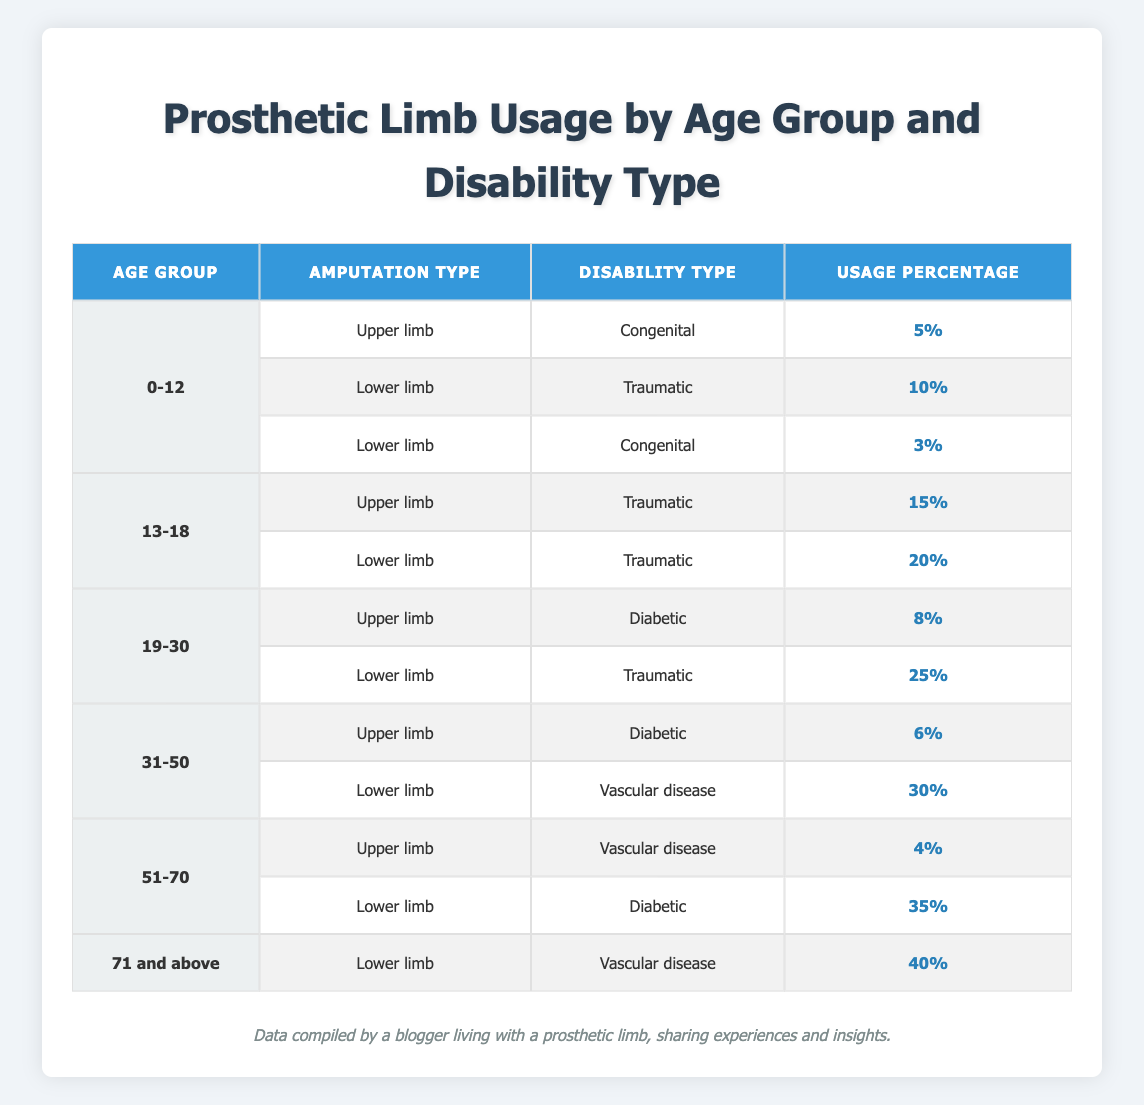What is the usage percentage for upper limb prosthetics among children aged 0-12 with congenital disabilities? In the table, we look for the row where the age group is 0-12, the amputation type is upper limb, and the disability type is congenital. There is one such row, which shows a usage percentage of 5%.
Answer: 5% Which age group has the highest usage percentage for lower limb prosthetics due to vascular disease? To answer this, we examine the rows for lower limb amputations with the disability type vascular disease. The only relevant row is for the age group 31-50, which displays a usage percentage of 30%. We then check the row for ages 51-70, but it refers to vascular disease for upper limbs. The row for ages 71 and above shows a usage percentage of 40%, but it isn't a lower limb. Therefore, the highest percentage for lower limbs due to vascular disease is in the age group 31-50.
Answer: 30% How many different disability types are represented for lower limb prosthetic usage in the age group 19-30? In the table, we look for the age group 19-30 and review the entries for lower limb prosthetics. There are two rows: one for traumatic disabilities and one for diabetic disabilities, resulting in two distinct disability types represented.
Answer: 2 What is the total usage percentage for upper limb prosthetics across all age groups? We need to find all rows with upper limb prosthetics and sum their usage percentages. The data for upper limb prosthetics are: 5% (0-12 congenital) + 15% (13-18 traumatic) + 8% (19-30 diabetic) + 6% (31-50 diabetic) + 4% (51-70 vascular disease) = 38%. Thus, the total usage percentage for upper limb prosthetics across all age groups is 38%.
Answer: 38% Is there a higher usage percentage for lower limb prosthetics among those aged 51-70 with diabetic disabilities compared to the 0-12 age group with congenital disabilities? For the age group 51-70, the lower limb usage for diabetic disabilities is 35%. For the age group 0-12, the lower limb usage for congenital disabilities is 3%. When comparing these numbers, 35% is greater than 3%, indicating that there is indeed a higher usage percentage among the older age group.
Answer: Yes What is the average usage percentage for lower limb prosthetics across all age groups? We sum the usage percentages for lower limb prosthetics from all relevant rows: 10% (0-12 traumatic) + 3% (0-12 congenital) + 20% (13-18 traumatic) + 25% (19-30 traumatic) + 30% (31-50 vascular disease) + 35% (51-70 diabetic) + 40% (71 and above vascular disease) = 163%. There are 7 data points, so we calculate the average as 163% / 7 = approximately 23.29%.
Answer: 23.29% 